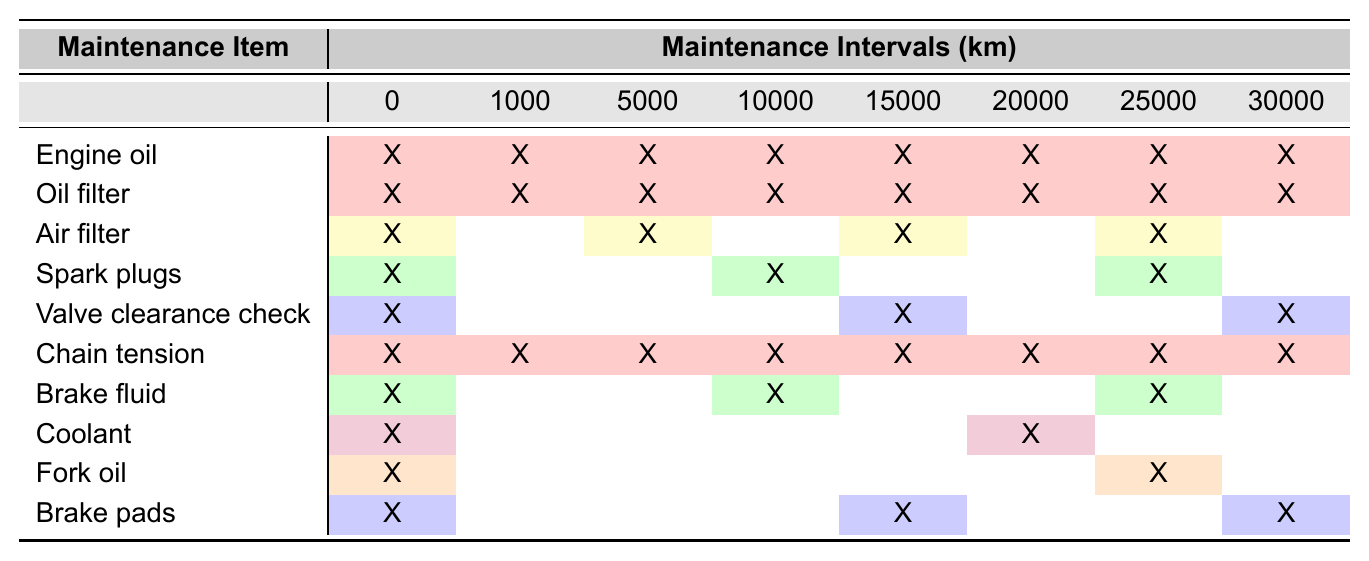What maintenance item should be replaced at 10,000 km? Referring to the table, we check the intervals for each item and find that 'Brake fluid' and 'Spark plugs' are marked for replacement at this interval.
Answer: Brake fluid and Spark plugs How many maintenance items need to be checked at the 1,000 km interval? By examining the table, we see that 'Engine oil', 'Oil filter', 'Chain tension', and 'Air filter' need to be checked at the 1,000 km mark, totaling four items.
Answer: Four items Is the 'Coolant' maintenance check required at 30,000 km? The table shows that 'Coolant' is marked for replacement only at 20,000 km, so it is not required at 30,000 km.
Answer: No What is the total number of maintenance checks required before 15,000 km? We count the items marked at 0 km, 1,000 km, 5,000 km, and 10,000 km. Totaling all marked items gives us 'Engine oil', 'Oil filter', 'Air filter', 'Chain tension', 'Brake pads', 'Brake fluid', 'Valve clearance check', which adds up to seven checks.
Answer: Seven checks At which intervals is 'Fork oil' scheduled for maintenance? Checking the intervals for 'Fork oil' in the table, it is specified to be maintained at 0 km and 25,000 km only.
Answer: 0 km and 25,000 km How often must the 'Valve clearance check' be performed from the start to 30,000 km? The table shows that it is due for checks at 0 km, 15,000 km, and 30,000 km; hence, it is performed three times in total until 30,000 km.
Answer: Three times Which item requires the least frequent checks and what is the interval? Looking at the table, 'Fork oil' requires maintenance at 25,000 km, which is the least frequent compared to other items, indicating a longer replacement interval.
Answer: 25,000 km What maintenance items will need to be replaced at 20,000 km? Referring to the table, the items that need replacing at 20,000 km include 'Coolant', 'Brake fluid', and 'Spark plugs'.
Answer: Coolant, Brake fluid, and Spark plugs How many intervals does 'Air filter' require a check before reaching 30,000 km? The 'Air filter' is scheduled for checks at 0 km, 5,000 km, and 15,000 km. Counting these gives it three intervals before reaching 30,000 km.
Answer: Three intervals Are 'Brake pads' and 'Fork oil' both checked at 15,000 km? The 'Brake pads' require checks at 15,000 km, while 'Fork oil' does not require a check until 25,000 km, confirming that they are not both checked at this interval.
Answer: No 